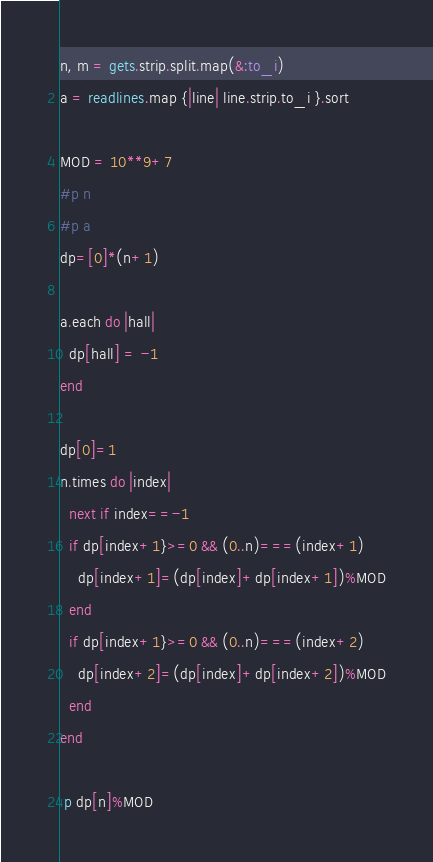Convert code to text. <code><loc_0><loc_0><loc_500><loc_500><_Ruby_>n, m = gets.strip.split.map(&:to_i)
a = readlines.map {|line| line.strip.to_i }.sort

MOD = 10**9+7
#p n
#p a
dp=[0]*(n+1)

a.each do |hall|
  dp[hall] = -1
end

dp[0]=1
n.times do |index|
  next if index==-1
  if dp[index+1}>=0 && (0..n)===(index+1)
    dp[index+1]=(dp[index]+dp[index+1])%MOD
  end
  if dp[index+1}>=0 && (0..n)===(index+2)
    dp[index+2]=(dp[index]+dp[index+2])%MOD
  end
end

 p dp[n]%MOD</code> 